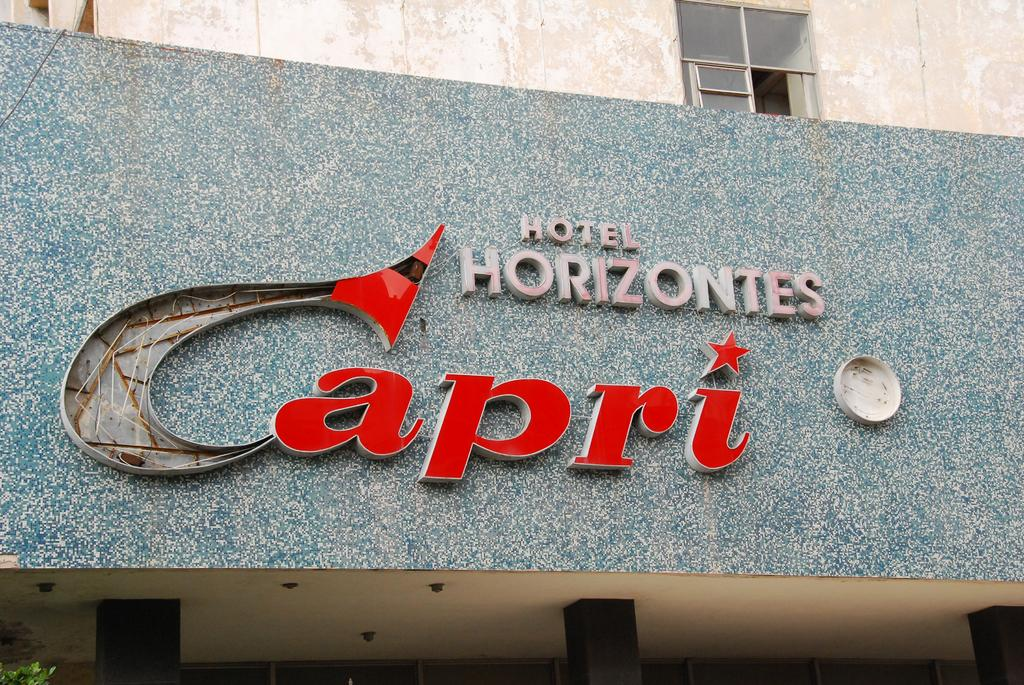<image>
Summarize the visual content of the image. Big sign that says Hotel Horizontes Capri on a building 